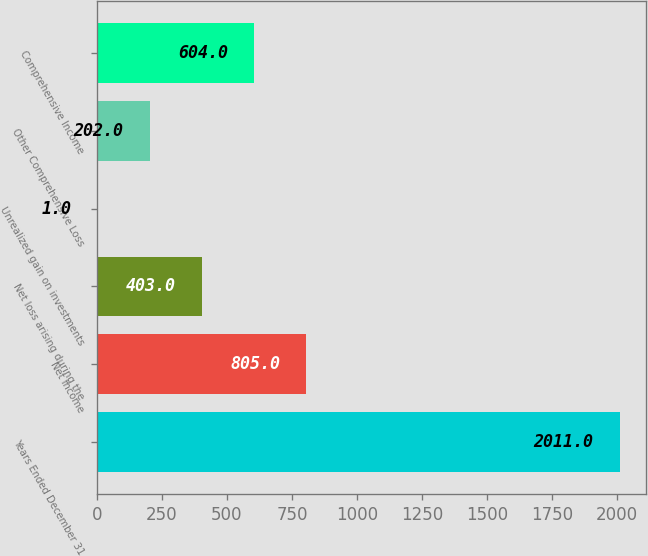Convert chart to OTSL. <chart><loc_0><loc_0><loc_500><loc_500><bar_chart><fcel>Years Ended December 31<fcel>Net Income<fcel>Net loss arising during the<fcel>Unrealized gain on investments<fcel>Other Comprehensive Loss<fcel>Comprehensive Income<nl><fcel>2011<fcel>805<fcel>403<fcel>1<fcel>202<fcel>604<nl></chart> 